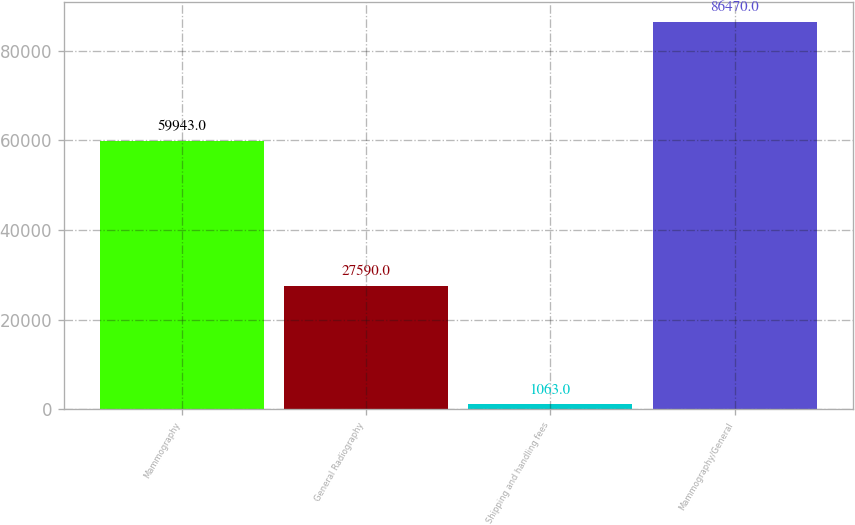Convert chart to OTSL. <chart><loc_0><loc_0><loc_500><loc_500><bar_chart><fcel>Mammography<fcel>General Radiography<fcel>Shipping and handling fees<fcel>Mammography/General<nl><fcel>59943<fcel>27590<fcel>1063<fcel>86470<nl></chart> 